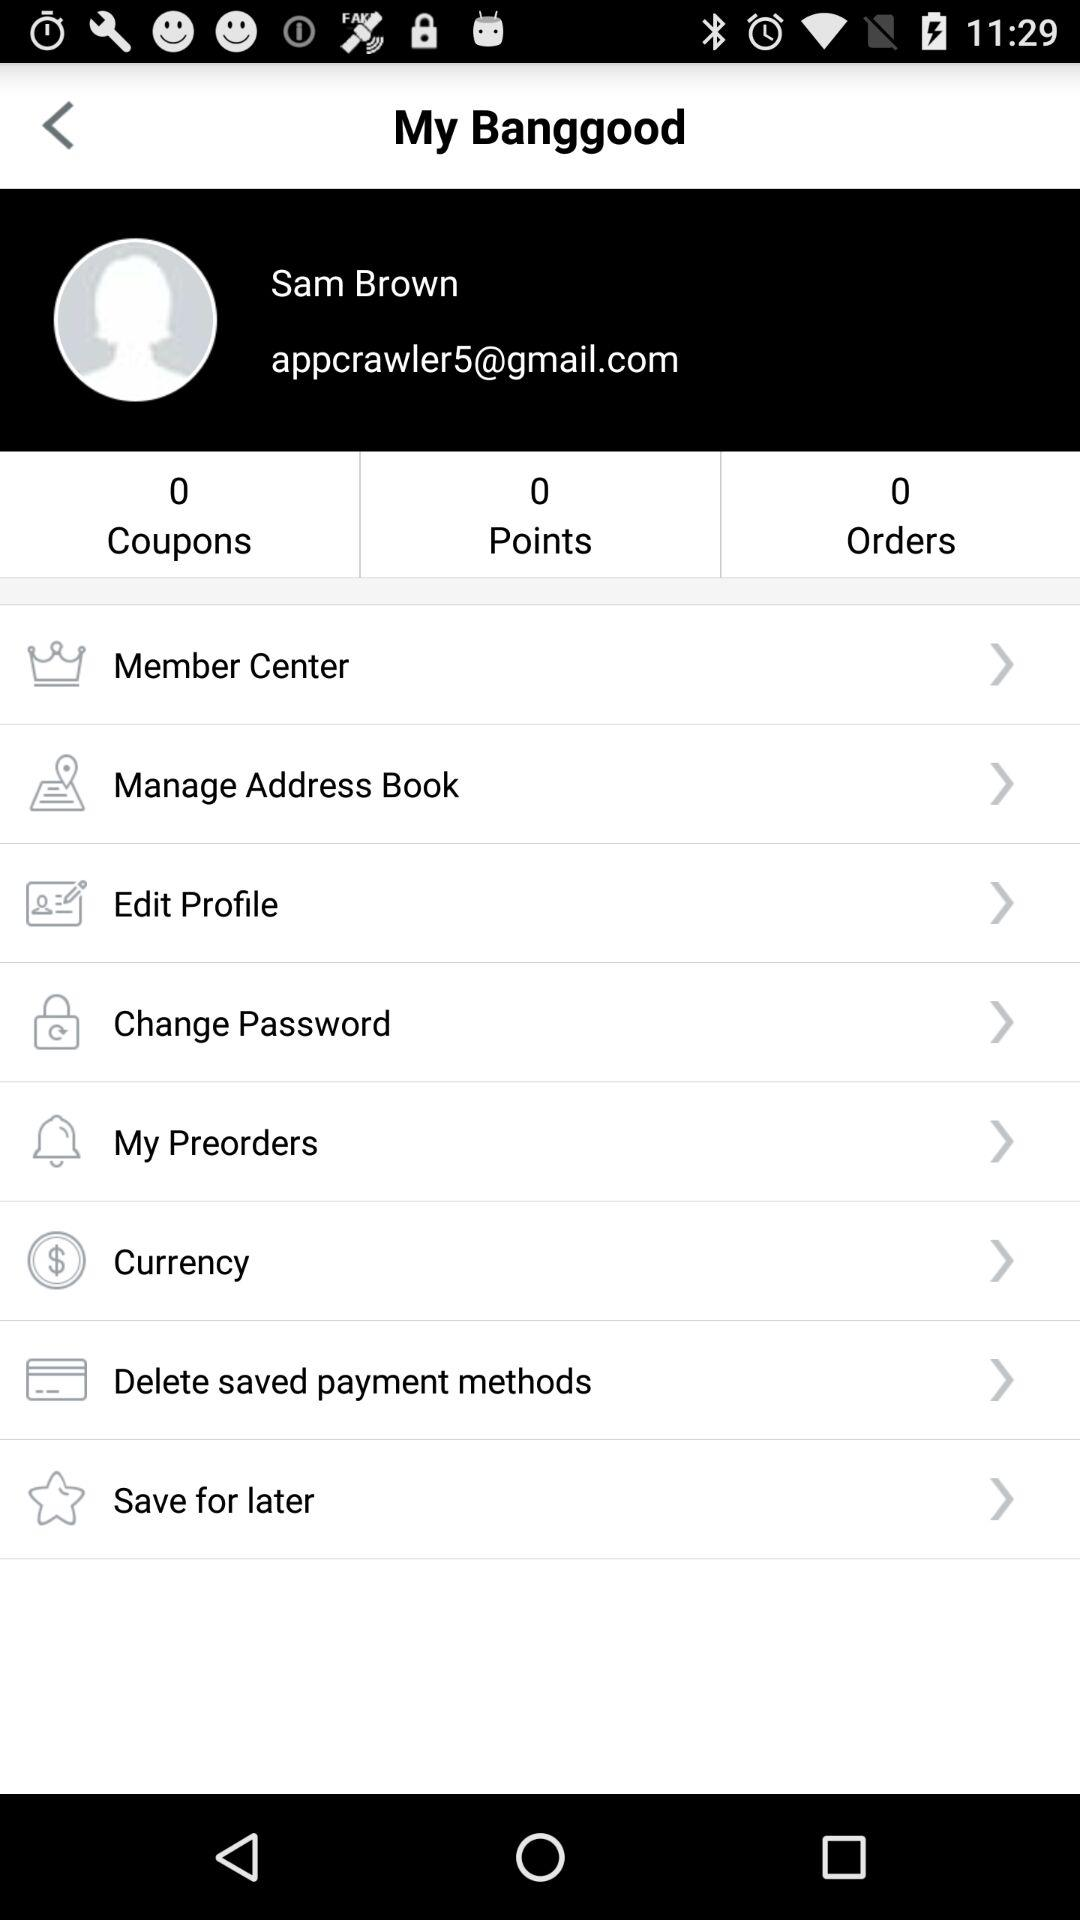What is the number of points? The number of points is 0. 